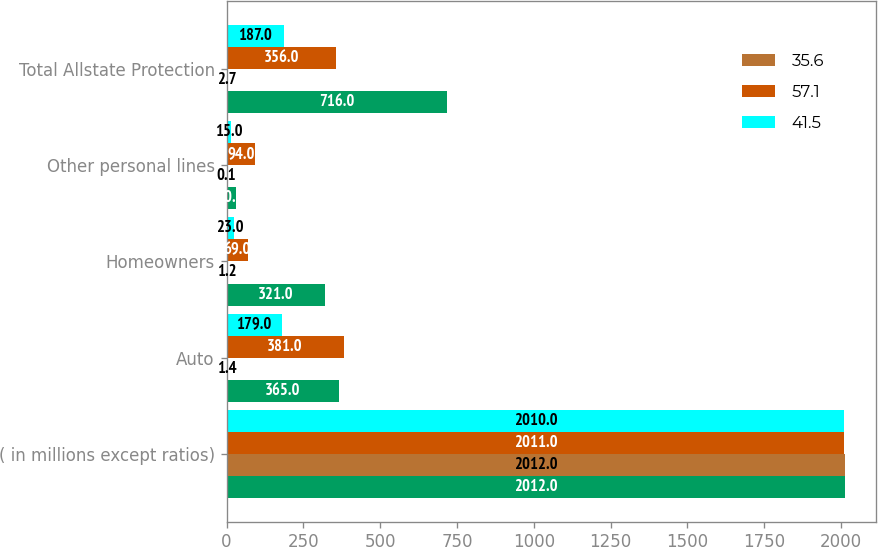Convert chart. <chart><loc_0><loc_0><loc_500><loc_500><stacked_bar_chart><ecel><fcel>( in millions except ratios)<fcel>Auto<fcel>Homeowners<fcel>Other personal lines<fcel>Total Allstate Protection<nl><fcel>nan<fcel>2012<fcel>365<fcel>321<fcel>30<fcel>716<nl><fcel>35.6<fcel>2012<fcel>1.4<fcel>1.2<fcel>0.1<fcel>2.7<nl><fcel>57.1<fcel>2011<fcel>381<fcel>69<fcel>94<fcel>356<nl><fcel>41.5<fcel>2010<fcel>179<fcel>23<fcel>15<fcel>187<nl></chart> 